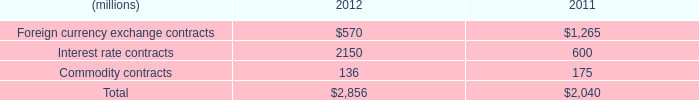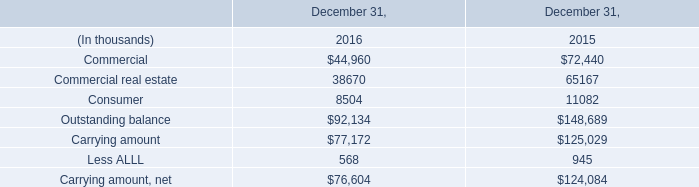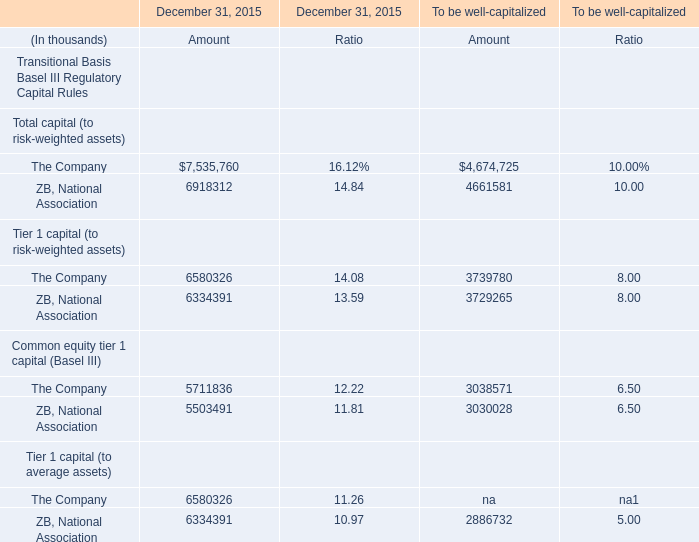in 2012 , what percent of the total notional amount is from foreign currency exchange contracts? 
Computations: (570 / 2856)
Answer: 0.19958. 